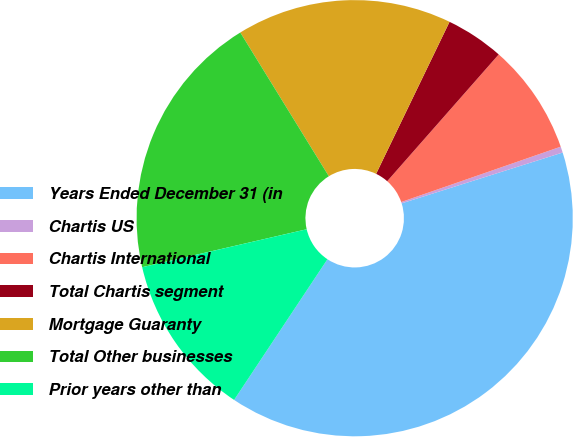Convert chart to OTSL. <chart><loc_0><loc_0><loc_500><loc_500><pie_chart><fcel>Years Ended December 31 (in<fcel>Chartis US<fcel>Chartis International<fcel>Total Chartis segment<fcel>Mortgage Guaranty<fcel>Total Other businesses<fcel>Prior years other than<nl><fcel>39.19%<fcel>0.45%<fcel>8.2%<fcel>4.32%<fcel>15.95%<fcel>19.82%<fcel>12.07%<nl></chart> 